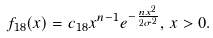<formula> <loc_0><loc_0><loc_500><loc_500>f _ { 1 8 } ( x ) = c _ { 1 8 } x ^ { n - 1 } e ^ { - \frac { n x ^ { 2 } } { 2 \sigma ^ { 2 } } } , \, x > 0 .</formula> 